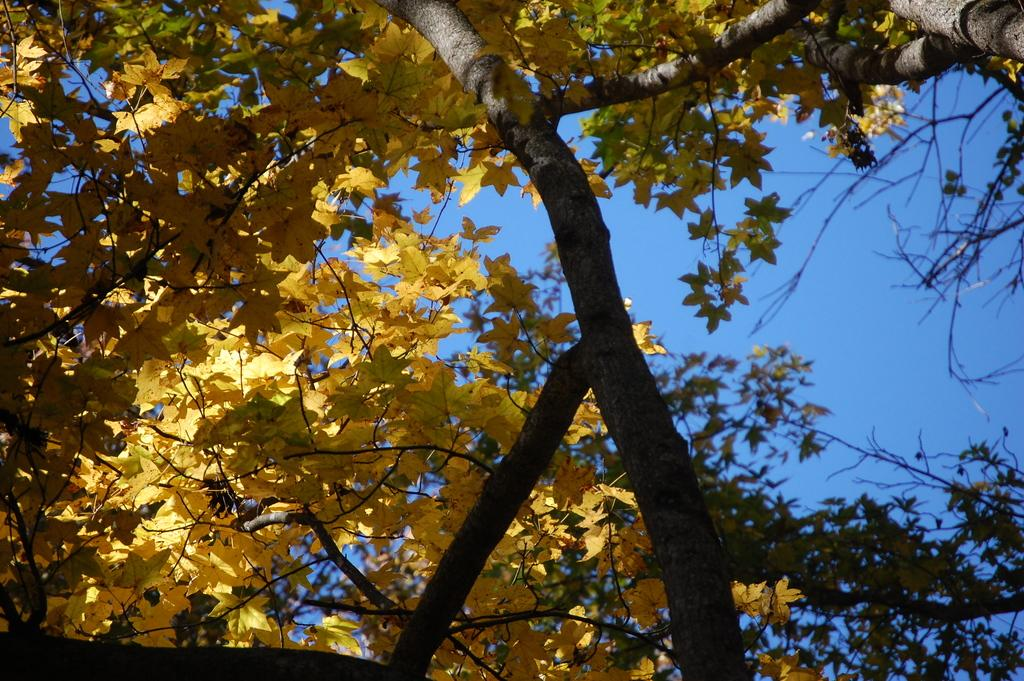What type of plant can be seen in the image? There is a tree in the image. What part of the natural environment is visible in the image? The sky is visible in the image. What type of board is being used for the nighttime activities in the image? There is no board or nighttime activities present in the image; it features a tree and the sky. 